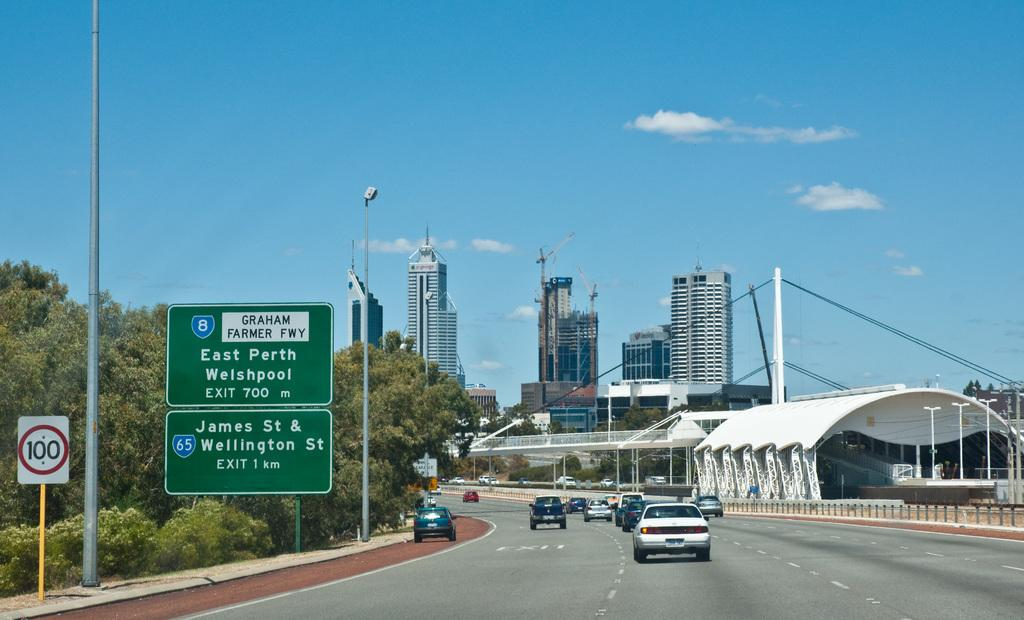Provide a one-sentence caption for the provided image. Cars are traveling on a freeway in Europe and next exit is East Porth Welshpool. 